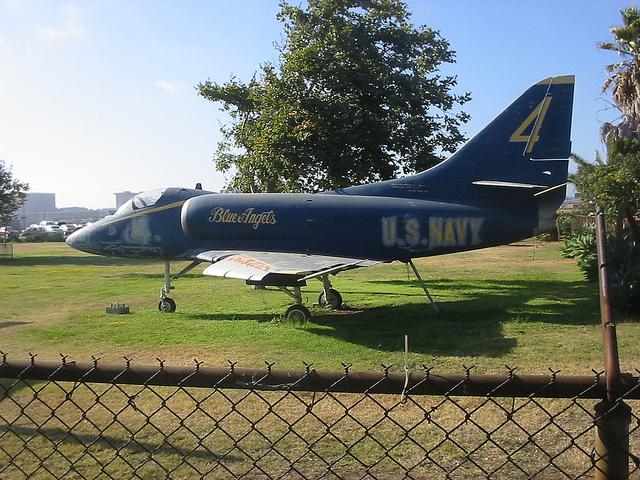What kind of fence is in the photo?
Write a very short answer. Chain link. Which branch of the service was this plane used in?
Give a very brief answer. Navy. What number is on the planes tail?
Short answer required. 4. 